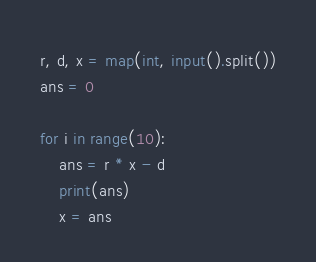<code> <loc_0><loc_0><loc_500><loc_500><_Python_>r, d, x = map(int, input().split())
ans = 0

for i in range(10):
	ans = r * x - d
	print(ans)
	x = ans</code> 